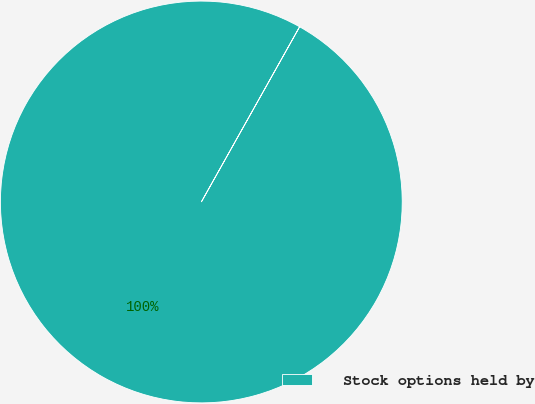Convert chart to OTSL. <chart><loc_0><loc_0><loc_500><loc_500><pie_chart><fcel>Stock options held by<nl><fcel>100.0%<nl></chart> 